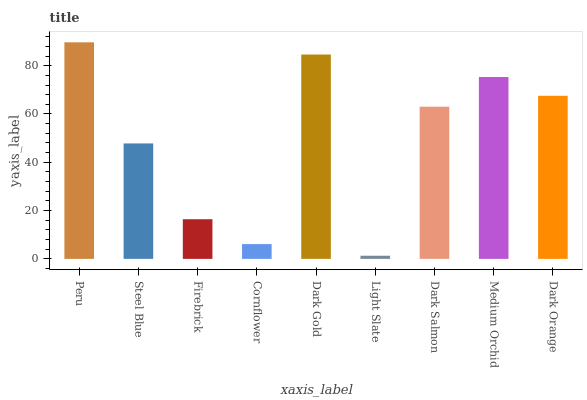Is Light Slate the minimum?
Answer yes or no. Yes. Is Peru the maximum?
Answer yes or no. Yes. Is Steel Blue the minimum?
Answer yes or no. No. Is Steel Blue the maximum?
Answer yes or no. No. Is Peru greater than Steel Blue?
Answer yes or no. Yes. Is Steel Blue less than Peru?
Answer yes or no. Yes. Is Steel Blue greater than Peru?
Answer yes or no. No. Is Peru less than Steel Blue?
Answer yes or no. No. Is Dark Salmon the high median?
Answer yes or no. Yes. Is Dark Salmon the low median?
Answer yes or no. Yes. Is Dark Orange the high median?
Answer yes or no. No. Is Dark Gold the low median?
Answer yes or no. No. 